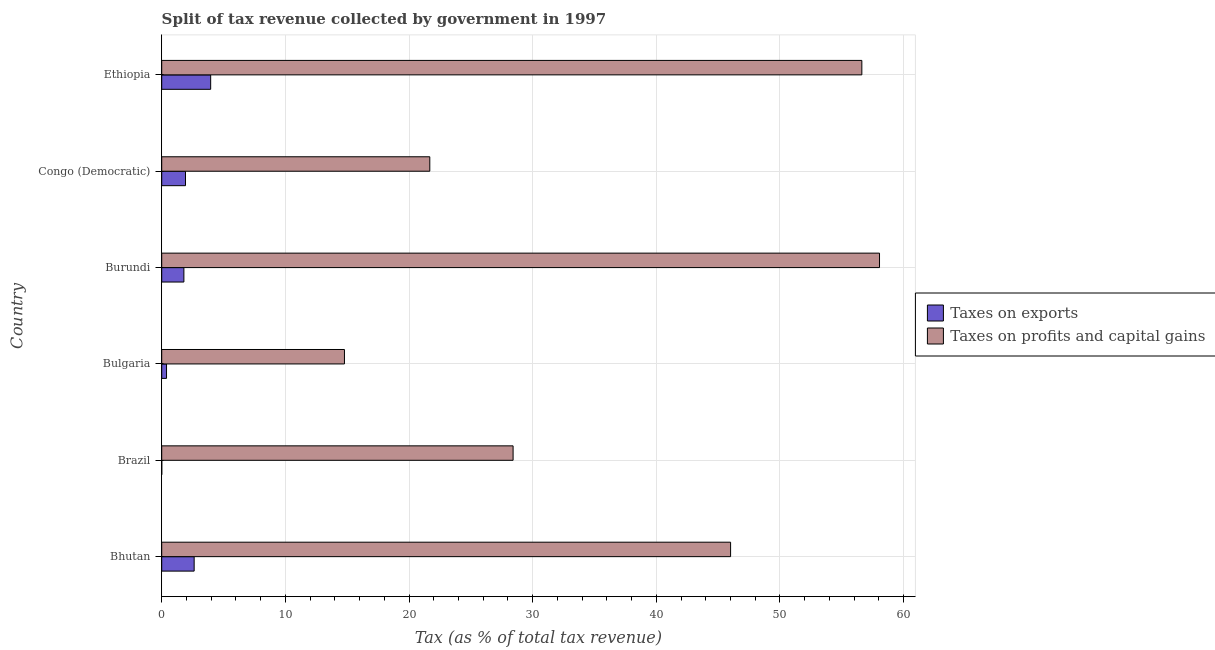How many different coloured bars are there?
Offer a very short reply. 2. How many groups of bars are there?
Your response must be concise. 6. Are the number of bars per tick equal to the number of legend labels?
Provide a succinct answer. Yes. Are the number of bars on each tick of the Y-axis equal?
Your answer should be compact. Yes. How many bars are there on the 2nd tick from the bottom?
Ensure brevity in your answer.  2. What is the label of the 6th group of bars from the top?
Keep it short and to the point. Bhutan. What is the percentage of revenue obtained from taxes on profits and capital gains in Bulgaria?
Your answer should be very brief. 14.78. Across all countries, what is the maximum percentage of revenue obtained from taxes on profits and capital gains?
Your answer should be very brief. 58.05. Across all countries, what is the minimum percentage of revenue obtained from taxes on profits and capital gains?
Offer a very short reply. 14.78. In which country was the percentage of revenue obtained from taxes on exports maximum?
Make the answer very short. Ethiopia. In which country was the percentage of revenue obtained from taxes on profits and capital gains minimum?
Ensure brevity in your answer.  Bulgaria. What is the total percentage of revenue obtained from taxes on profits and capital gains in the graph?
Offer a terse response. 225.56. What is the difference between the percentage of revenue obtained from taxes on exports in Bhutan and that in Ethiopia?
Your answer should be very brief. -1.34. What is the difference between the percentage of revenue obtained from taxes on exports in Bulgaria and the percentage of revenue obtained from taxes on profits and capital gains in Congo (Democratic)?
Make the answer very short. -21.29. What is the average percentage of revenue obtained from taxes on profits and capital gains per country?
Offer a very short reply. 37.59. What is the difference between the percentage of revenue obtained from taxes on exports and percentage of revenue obtained from taxes on profits and capital gains in Congo (Democratic)?
Provide a short and direct response. -19.76. In how many countries, is the percentage of revenue obtained from taxes on profits and capital gains greater than 2 %?
Keep it short and to the point. 6. What is the ratio of the percentage of revenue obtained from taxes on exports in Congo (Democratic) to that in Ethiopia?
Your answer should be compact. 0.49. Is the percentage of revenue obtained from taxes on profits and capital gains in Burundi less than that in Ethiopia?
Your response must be concise. No. What is the difference between the highest and the second highest percentage of revenue obtained from taxes on profits and capital gains?
Offer a terse response. 1.43. What is the difference between the highest and the lowest percentage of revenue obtained from taxes on profits and capital gains?
Provide a short and direct response. 43.27. In how many countries, is the percentage of revenue obtained from taxes on exports greater than the average percentage of revenue obtained from taxes on exports taken over all countries?
Ensure brevity in your answer.  4. Is the sum of the percentage of revenue obtained from taxes on exports in Bhutan and Brazil greater than the maximum percentage of revenue obtained from taxes on profits and capital gains across all countries?
Your answer should be very brief. No. What does the 2nd bar from the top in Bhutan represents?
Ensure brevity in your answer.  Taxes on exports. What does the 1st bar from the bottom in Ethiopia represents?
Offer a very short reply. Taxes on exports. Are all the bars in the graph horizontal?
Your answer should be compact. Yes. Where does the legend appear in the graph?
Keep it short and to the point. Center right. How many legend labels are there?
Ensure brevity in your answer.  2. What is the title of the graph?
Give a very brief answer. Split of tax revenue collected by government in 1997. Does "Frequency of shipment arrival" appear as one of the legend labels in the graph?
Offer a terse response. No. What is the label or title of the X-axis?
Make the answer very short. Tax (as % of total tax revenue). What is the label or title of the Y-axis?
Your response must be concise. Country. What is the Tax (as % of total tax revenue) in Taxes on exports in Bhutan?
Your answer should be very brief. 2.62. What is the Tax (as % of total tax revenue) of Taxes on profits and capital gains in Bhutan?
Make the answer very short. 46.01. What is the Tax (as % of total tax revenue) in Taxes on exports in Brazil?
Give a very brief answer. 0. What is the Tax (as % of total tax revenue) in Taxes on profits and capital gains in Brazil?
Make the answer very short. 28.42. What is the Tax (as % of total tax revenue) of Taxes on exports in Bulgaria?
Your answer should be compact. 0.39. What is the Tax (as % of total tax revenue) in Taxes on profits and capital gains in Bulgaria?
Give a very brief answer. 14.78. What is the Tax (as % of total tax revenue) of Taxes on exports in Burundi?
Your answer should be compact. 1.79. What is the Tax (as % of total tax revenue) in Taxes on profits and capital gains in Burundi?
Ensure brevity in your answer.  58.05. What is the Tax (as % of total tax revenue) of Taxes on exports in Congo (Democratic)?
Make the answer very short. 1.92. What is the Tax (as % of total tax revenue) of Taxes on profits and capital gains in Congo (Democratic)?
Give a very brief answer. 21.68. What is the Tax (as % of total tax revenue) in Taxes on exports in Ethiopia?
Offer a terse response. 3.96. What is the Tax (as % of total tax revenue) of Taxes on profits and capital gains in Ethiopia?
Offer a terse response. 56.62. Across all countries, what is the maximum Tax (as % of total tax revenue) of Taxes on exports?
Provide a short and direct response. 3.96. Across all countries, what is the maximum Tax (as % of total tax revenue) in Taxes on profits and capital gains?
Your response must be concise. 58.05. Across all countries, what is the minimum Tax (as % of total tax revenue) of Taxes on exports?
Your answer should be very brief. 0. Across all countries, what is the minimum Tax (as % of total tax revenue) of Taxes on profits and capital gains?
Your answer should be very brief. 14.78. What is the total Tax (as % of total tax revenue) of Taxes on exports in the graph?
Your answer should be very brief. 10.69. What is the total Tax (as % of total tax revenue) in Taxes on profits and capital gains in the graph?
Ensure brevity in your answer.  225.56. What is the difference between the Tax (as % of total tax revenue) of Taxes on exports in Bhutan and that in Brazil?
Your answer should be very brief. 2.62. What is the difference between the Tax (as % of total tax revenue) of Taxes on profits and capital gains in Bhutan and that in Brazil?
Your answer should be compact. 17.59. What is the difference between the Tax (as % of total tax revenue) in Taxes on exports in Bhutan and that in Bulgaria?
Your answer should be very brief. 2.23. What is the difference between the Tax (as % of total tax revenue) of Taxes on profits and capital gains in Bhutan and that in Bulgaria?
Your response must be concise. 31.23. What is the difference between the Tax (as % of total tax revenue) in Taxes on exports in Bhutan and that in Burundi?
Make the answer very short. 0.83. What is the difference between the Tax (as % of total tax revenue) of Taxes on profits and capital gains in Bhutan and that in Burundi?
Keep it short and to the point. -12.04. What is the difference between the Tax (as % of total tax revenue) of Taxes on exports in Bhutan and that in Congo (Democratic)?
Your answer should be very brief. 0.7. What is the difference between the Tax (as % of total tax revenue) in Taxes on profits and capital gains in Bhutan and that in Congo (Democratic)?
Ensure brevity in your answer.  24.33. What is the difference between the Tax (as % of total tax revenue) of Taxes on exports in Bhutan and that in Ethiopia?
Make the answer very short. -1.34. What is the difference between the Tax (as % of total tax revenue) in Taxes on profits and capital gains in Bhutan and that in Ethiopia?
Your answer should be very brief. -10.61. What is the difference between the Tax (as % of total tax revenue) in Taxes on exports in Brazil and that in Bulgaria?
Keep it short and to the point. -0.39. What is the difference between the Tax (as % of total tax revenue) of Taxes on profits and capital gains in Brazil and that in Bulgaria?
Offer a very short reply. 13.64. What is the difference between the Tax (as % of total tax revenue) in Taxes on exports in Brazil and that in Burundi?
Provide a short and direct response. -1.79. What is the difference between the Tax (as % of total tax revenue) of Taxes on profits and capital gains in Brazil and that in Burundi?
Provide a succinct answer. -29.63. What is the difference between the Tax (as % of total tax revenue) in Taxes on exports in Brazil and that in Congo (Democratic)?
Make the answer very short. -1.92. What is the difference between the Tax (as % of total tax revenue) in Taxes on profits and capital gains in Brazil and that in Congo (Democratic)?
Give a very brief answer. 6.74. What is the difference between the Tax (as % of total tax revenue) of Taxes on exports in Brazil and that in Ethiopia?
Offer a terse response. -3.96. What is the difference between the Tax (as % of total tax revenue) of Taxes on profits and capital gains in Brazil and that in Ethiopia?
Your answer should be very brief. -28.2. What is the difference between the Tax (as % of total tax revenue) in Taxes on exports in Bulgaria and that in Burundi?
Your answer should be compact. -1.4. What is the difference between the Tax (as % of total tax revenue) in Taxes on profits and capital gains in Bulgaria and that in Burundi?
Provide a succinct answer. -43.27. What is the difference between the Tax (as % of total tax revenue) of Taxes on exports in Bulgaria and that in Congo (Democratic)?
Your answer should be compact. -1.53. What is the difference between the Tax (as % of total tax revenue) of Taxes on profits and capital gains in Bulgaria and that in Congo (Democratic)?
Give a very brief answer. -6.9. What is the difference between the Tax (as % of total tax revenue) in Taxes on exports in Bulgaria and that in Ethiopia?
Offer a terse response. -3.57. What is the difference between the Tax (as % of total tax revenue) in Taxes on profits and capital gains in Bulgaria and that in Ethiopia?
Keep it short and to the point. -41.84. What is the difference between the Tax (as % of total tax revenue) of Taxes on exports in Burundi and that in Congo (Democratic)?
Give a very brief answer. -0.13. What is the difference between the Tax (as % of total tax revenue) of Taxes on profits and capital gains in Burundi and that in Congo (Democratic)?
Ensure brevity in your answer.  36.37. What is the difference between the Tax (as % of total tax revenue) of Taxes on exports in Burundi and that in Ethiopia?
Your answer should be very brief. -2.17. What is the difference between the Tax (as % of total tax revenue) of Taxes on profits and capital gains in Burundi and that in Ethiopia?
Offer a terse response. 1.43. What is the difference between the Tax (as % of total tax revenue) in Taxes on exports in Congo (Democratic) and that in Ethiopia?
Provide a succinct answer. -2.04. What is the difference between the Tax (as % of total tax revenue) of Taxes on profits and capital gains in Congo (Democratic) and that in Ethiopia?
Your answer should be very brief. -34.94. What is the difference between the Tax (as % of total tax revenue) of Taxes on exports in Bhutan and the Tax (as % of total tax revenue) of Taxes on profits and capital gains in Brazil?
Provide a succinct answer. -25.79. What is the difference between the Tax (as % of total tax revenue) in Taxes on exports in Bhutan and the Tax (as % of total tax revenue) in Taxes on profits and capital gains in Bulgaria?
Give a very brief answer. -12.16. What is the difference between the Tax (as % of total tax revenue) in Taxes on exports in Bhutan and the Tax (as % of total tax revenue) in Taxes on profits and capital gains in Burundi?
Make the answer very short. -55.43. What is the difference between the Tax (as % of total tax revenue) of Taxes on exports in Bhutan and the Tax (as % of total tax revenue) of Taxes on profits and capital gains in Congo (Democratic)?
Your answer should be very brief. -19.06. What is the difference between the Tax (as % of total tax revenue) in Taxes on exports in Bhutan and the Tax (as % of total tax revenue) in Taxes on profits and capital gains in Ethiopia?
Provide a short and direct response. -54. What is the difference between the Tax (as % of total tax revenue) in Taxes on exports in Brazil and the Tax (as % of total tax revenue) in Taxes on profits and capital gains in Bulgaria?
Offer a terse response. -14.78. What is the difference between the Tax (as % of total tax revenue) in Taxes on exports in Brazil and the Tax (as % of total tax revenue) in Taxes on profits and capital gains in Burundi?
Ensure brevity in your answer.  -58.05. What is the difference between the Tax (as % of total tax revenue) in Taxes on exports in Brazil and the Tax (as % of total tax revenue) in Taxes on profits and capital gains in Congo (Democratic)?
Give a very brief answer. -21.68. What is the difference between the Tax (as % of total tax revenue) of Taxes on exports in Brazil and the Tax (as % of total tax revenue) of Taxes on profits and capital gains in Ethiopia?
Your answer should be compact. -56.62. What is the difference between the Tax (as % of total tax revenue) of Taxes on exports in Bulgaria and the Tax (as % of total tax revenue) of Taxes on profits and capital gains in Burundi?
Offer a terse response. -57.66. What is the difference between the Tax (as % of total tax revenue) in Taxes on exports in Bulgaria and the Tax (as % of total tax revenue) in Taxes on profits and capital gains in Congo (Democratic)?
Provide a short and direct response. -21.29. What is the difference between the Tax (as % of total tax revenue) of Taxes on exports in Bulgaria and the Tax (as % of total tax revenue) of Taxes on profits and capital gains in Ethiopia?
Your answer should be compact. -56.23. What is the difference between the Tax (as % of total tax revenue) of Taxes on exports in Burundi and the Tax (as % of total tax revenue) of Taxes on profits and capital gains in Congo (Democratic)?
Offer a very short reply. -19.89. What is the difference between the Tax (as % of total tax revenue) in Taxes on exports in Burundi and the Tax (as % of total tax revenue) in Taxes on profits and capital gains in Ethiopia?
Offer a very short reply. -54.83. What is the difference between the Tax (as % of total tax revenue) in Taxes on exports in Congo (Democratic) and the Tax (as % of total tax revenue) in Taxes on profits and capital gains in Ethiopia?
Offer a terse response. -54.7. What is the average Tax (as % of total tax revenue) in Taxes on exports per country?
Your response must be concise. 1.78. What is the average Tax (as % of total tax revenue) in Taxes on profits and capital gains per country?
Provide a succinct answer. 37.59. What is the difference between the Tax (as % of total tax revenue) in Taxes on exports and Tax (as % of total tax revenue) in Taxes on profits and capital gains in Bhutan?
Provide a short and direct response. -43.38. What is the difference between the Tax (as % of total tax revenue) in Taxes on exports and Tax (as % of total tax revenue) in Taxes on profits and capital gains in Brazil?
Provide a succinct answer. -28.42. What is the difference between the Tax (as % of total tax revenue) in Taxes on exports and Tax (as % of total tax revenue) in Taxes on profits and capital gains in Bulgaria?
Your response must be concise. -14.39. What is the difference between the Tax (as % of total tax revenue) of Taxes on exports and Tax (as % of total tax revenue) of Taxes on profits and capital gains in Burundi?
Your answer should be compact. -56.26. What is the difference between the Tax (as % of total tax revenue) in Taxes on exports and Tax (as % of total tax revenue) in Taxes on profits and capital gains in Congo (Democratic)?
Your answer should be compact. -19.76. What is the difference between the Tax (as % of total tax revenue) in Taxes on exports and Tax (as % of total tax revenue) in Taxes on profits and capital gains in Ethiopia?
Offer a very short reply. -52.66. What is the ratio of the Tax (as % of total tax revenue) of Taxes on exports in Bhutan to that in Brazil?
Make the answer very short. 878.32. What is the ratio of the Tax (as % of total tax revenue) in Taxes on profits and capital gains in Bhutan to that in Brazil?
Provide a short and direct response. 1.62. What is the ratio of the Tax (as % of total tax revenue) in Taxes on exports in Bhutan to that in Bulgaria?
Provide a short and direct response. 6.72. What is the ratio of the Tax (as % of total tax revenue) of Taxes on profits and capital gains in Bhutan to that in Bulgaria?
Give a very brief answer. 3.11. What is the ratio of the Tax (as % of total tax revenue) of Taxes on exports in Bhutan to that in Burundi?
Your response must be concise. 1.46. What is the ratio of the Tax (as % of total tax revenue) in Taxes on profits and capital gains in Bhutan to that in Burundi?
Keep it short and to the point. 0.79. What is the ratio of the Tax (as % of total tax revenue) of Taxes on exports in Bhutan to that in Congo (Democratic)?
Offer a very short reply. 1.36. What is the ratio of the Tax (as % of total tax revenue) of Taxes on profits and capital gains in Bhutan to that in Congo (Democratic)?
Ensure brevity in your answer.  2.12. What is the ratio of the Tax (as % of total tax revenue) in Taxes on exports in Bhutan to that in Ethiopia?
Your response must be concise. 0.66. What is the ratio of the Tax (as % of total tax revenue) of Taxes on profits and capital gains in Bhutan to that in Ethiopia?
Provide a succinct answer. 0.81. What is the ratio of the Tax (as % of total tax revenue) in Taxes on exports in Brazil to that in Bulgaria?
Provide a succinct answer. 0.01. What is the ratio of the Tax (as % of total tax revenue) in Taxes on profits and capital gains in Brazil to that in Bulgaria?
Offer a very short reply. 1.92. What is the ratio of the Tax (as % of total tax revenue) of Taxes on exports in Brazil to that in Burundi?
Provide a succinct answer. 0. What is the ratio of the Tax (as % of total tax revenue) of Taxes on profits and capital gains in Brazil to that in Burundi?
Give a very brief answer. 0.49. What is the ratio of the Tax (as % of total tax revenue) of Taxes on exports in Brazil to that in Congo (Democratic)?
Offer a terse response. 0. What is the ratio of the Tax (as % of total tax revenue) of Taxes on profits and capital gains in Brazil to that in Congo (Democratic)?
Your answer should be compact. 1.31. What is the ratio of the Tax (as % of total tax revenue) of Taxes on exports in Brazil to that in Ethiopia?
Provide a short and direct response. 0. What is the ratio of the Tax (as % of total tax revenue) of Taxes on profits and capital gains in Brazil to that in Ethiopia?
Make the answer very short. 0.5. What is the ratio of the Tax (as % of total tax revenue) in Taxes on exports in Bulgaria to that in Burundi?
Offer a very short reply. 0.22. What is the ratio of the Tax (as % of total tax revenue) of Taxes on profits and capital gains in Bulgaria to that in Burundi?
Give a very brief answer. 0.25. What is the ratio of the Tax (as % of total tax revenue) of Taxes on exports in Bulgaria to that in Congo (Democratic)?
Your answer should be compact. 0.2. What is the ratio of the Tax (as % of total tax revenue) in Taxes on profits and capital gains in Bulgaria to that in Congo (Democratic)?
Give a very brief answer. 0.68. What is the ratio of the Tax (as % of total tax revenue) in Taxes on exports in Bulgaria to that in Ethiopia?
Provide a short and direct response. 0.1. What is the ratio of the Tax (as % of total tax revenue) in Taxes on profits and capital gains in Bulgaria to that in Ethiopia?
Provide a succinct answer. 0.26. What is the ratio of the Tax (as % of total tax revenue) of Taxes on exports in Burundi to that in Congo (Democratic)?
Ensure brevity in your answer.  0.93. What is the ratio of the Tax (as % of total tax revenue) of Taxes on profits and capital gains in Burundi to that in Congo (Democratic)?
Your answer should be compact. 2.68. What is the ratio of the Tax (as % of total tax revenue) of Taxes on exports in Burundi to that in Ethiopia?
Ensure brevity in your answer.  0.45. What is the ratio of the Tax (as % of total tax revenue) of Taxes on profits and capital gains in Burundi to that in Ethiopia?
Keep it short and to the point. 1.03. What is the ratio of the Tax (as % of total tax revenue) of Taxes on exports in Congo (Democratic) to that in Ethiopia?
Your answer should be compact. 0.49. What is the ratio of the Tax (as % of total tax revenue) of Taxes on profits and capital gains in Congo (Democratic) to that in Ethiopia?
Provide a succinct answer. 0.38. What is the difference between the highest and the second highest Tax (as % of total tax revenue) in Taxes on exports?
Provide a short and direct response. 1.34. What is the difference between the highest and the second highest Tax (as % of total tax revenue) of Taxes on profits and capital gains?
Offer a very short reply. 1.43. What is the difference between the highest and the lowest Tax (as % of total tax revenue) of Taxes on exports?
Offer a terse response. 3.96. What is the difference between the highest and the lowest Tax (as % of total tax revenue) of Taxes on profits and capital gains?
Your response must be concise. 43.27. 